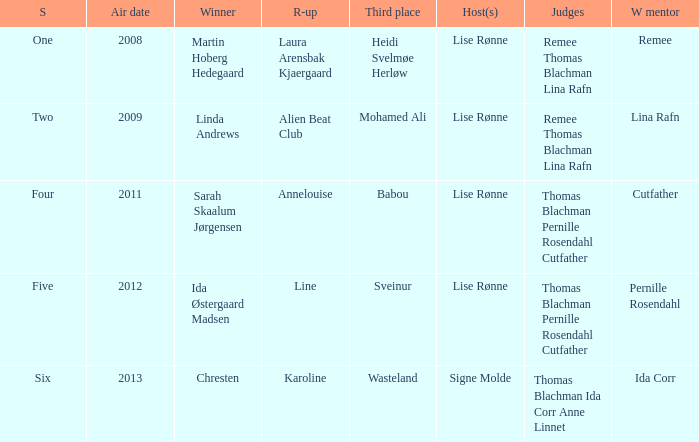Which season did Ida Corr win? Six. 